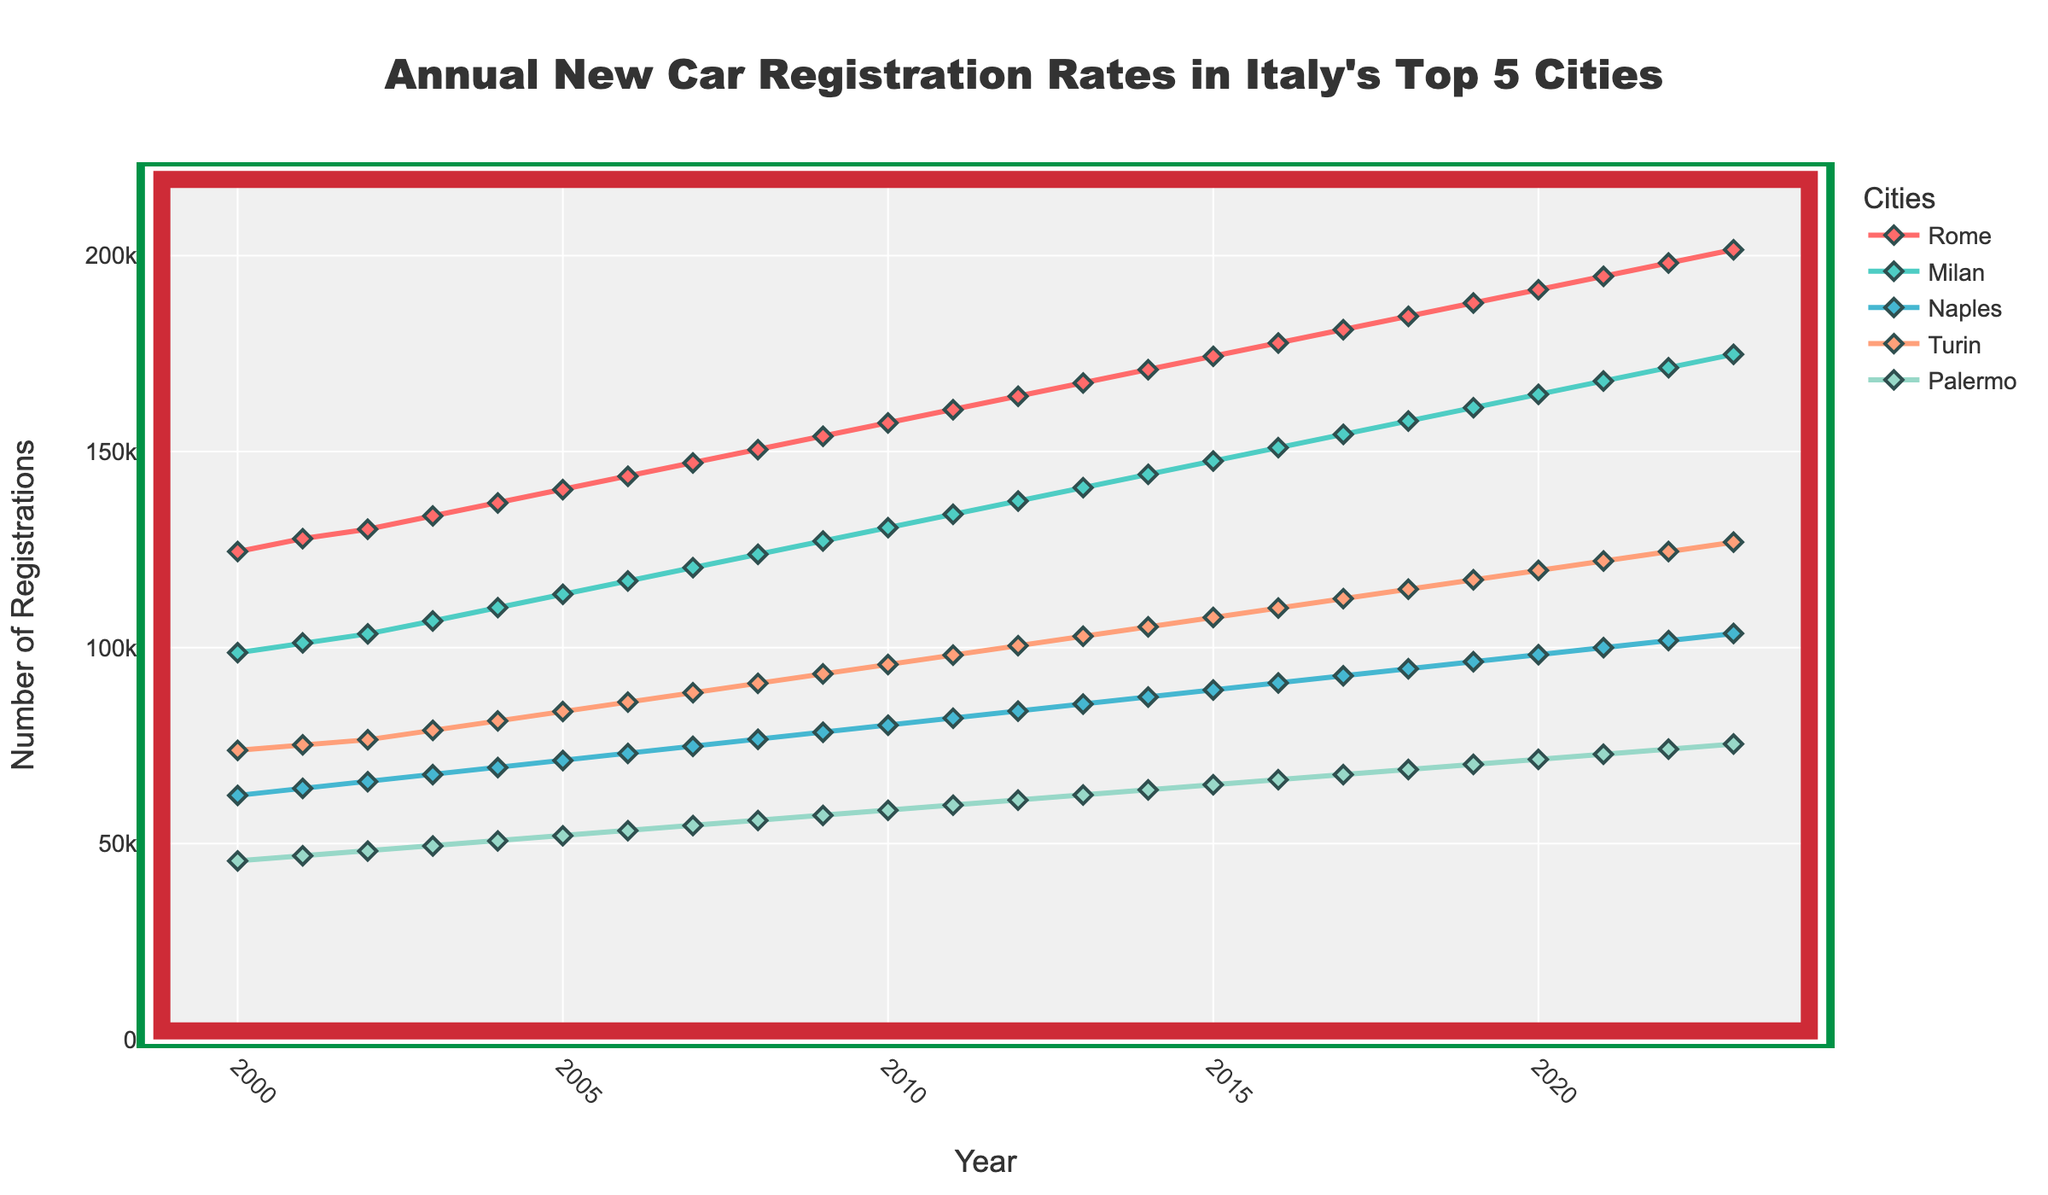What's the trend in Rome's car registrations from 2000 to 2023? Look at the line representing Rome. The trend is generally increasing over the years.
Answer: Increasing Which city had the least number of car registrations in 2023? Compare the endpoints (2023) of all the lines. Palermo has the lowest value.
Answer: Palermo By how many units did the number of car registrations in Milan increase from 2000 to 2023? Find the car registrations in Milan for both years and subtract. 174800 (2023) - 98700 (2000) = 76000
Answer: 76000 Which two cities had the closest number of car registrations in 2010, and what’s the difference? Compare the values for 2010 and look for the closest numbers. Naples (80200) and Palermo (58500). Difference = 80200 - 58500 = 21700
Answer: Naples and Palermo, 21700 How does the growth rate in registrations for Turin compare to Palermo from 2000 to 2023? Calculate the difference in registrations from 2000 to 2023 for both cities. Turin: 126900 - 73800 = 53000, Palermo: 75400 - 45600 = 29800. Turin’s growth is greater.
Answer: Turin's growth is greater In which year did Naples surpass 80000 registrations for the first time? Look at the trend line for Naples and identify the first year it crosses 80000. This happens in 2011.
Answer: 2011 What is the average annual increase in car registrations for Rome between 2000 and 2023? Calculate the total increase (201500 - 124500) and divide by the number of years (2023 - 2000). The increase is 77000 / 23 = ~3348 units/year.
Answer: ~3348 units/year Which city experienced the largest increase in car registrations between 2009 and 2010? Compare the differences between 2009 and 2010 for each city. Rome: 157300-153900=3400, Milan: 130600-127200=3400, Naples: 80200-78400=1800, Turin: 95700-93300=2400, Palermo: 58500-57200=1300. Rome and Milan both had the largest increase.
Answer: Rome and Milan What are the registration counts for Naples and Turin in 2015, and how do they compare? Note the values for Naples (89200) and Turin (107700) in 2015 and compare them. Turin's count is greater.
Answer: Naples: 89200, Turin: 107700, Turin is higher Which city had the fastest-growing registration rate from 2018 to 2023? Calculate the growth for each city over these years. Rome: 201500-184500=17000, Milan: 174800-157800=17000, Naples: 103600-94600=9000, Turin: 126900-114900=12000, Palermo: 75400-68900=6500. Rome and Milan both have the fastest growth.
Answer: Rome and Milan 